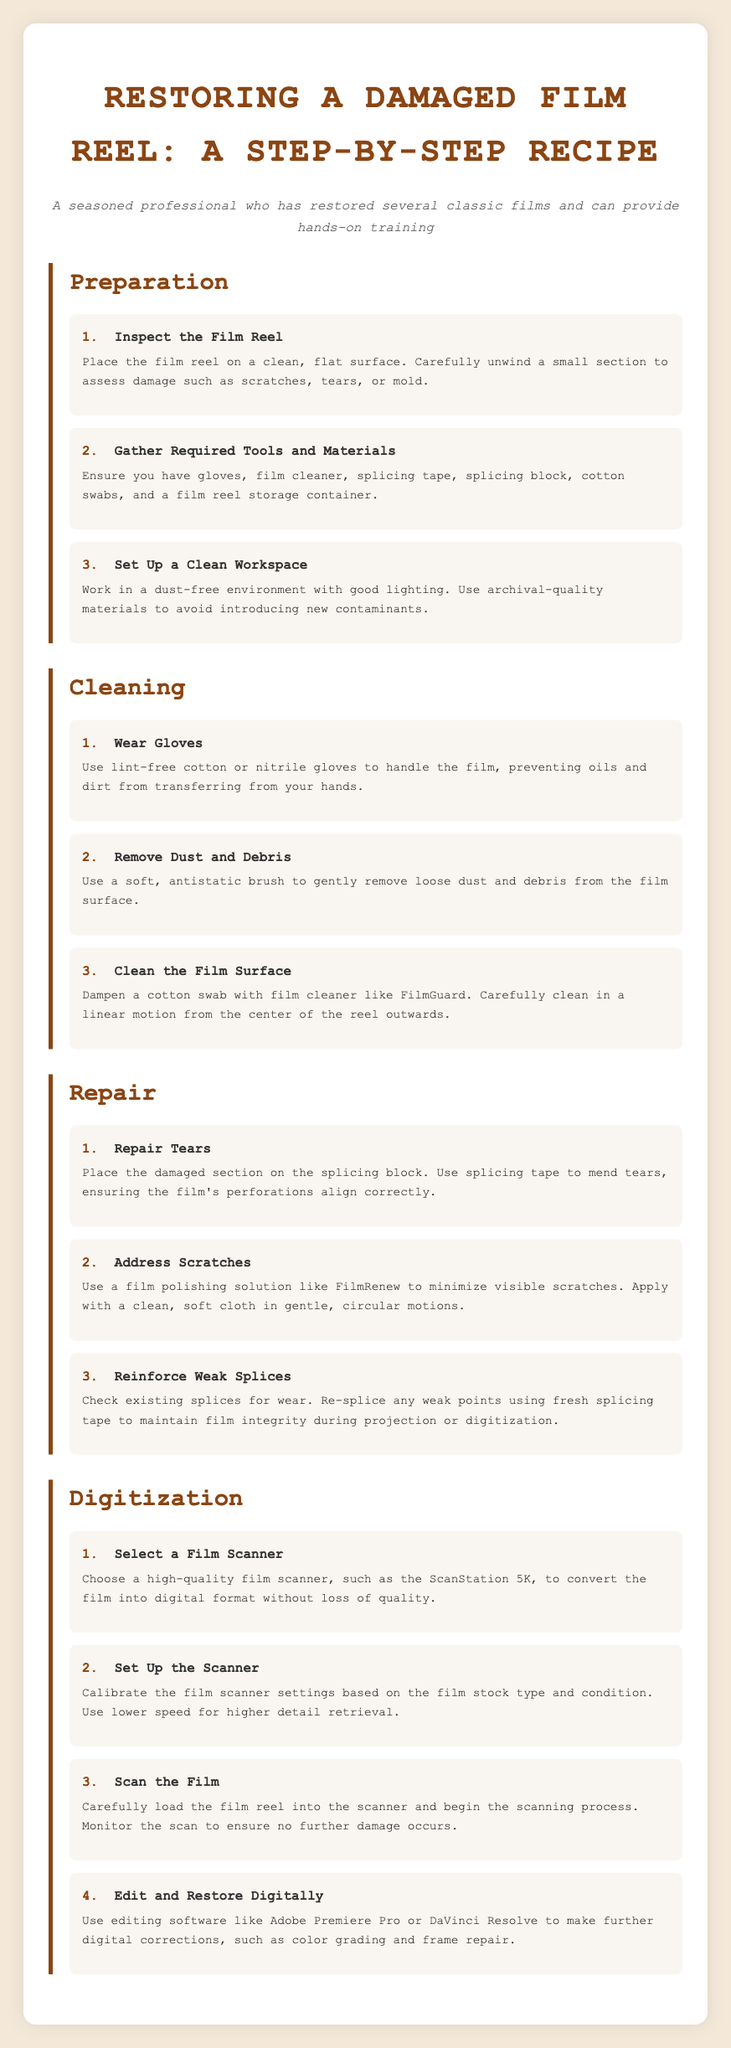What is the first step in the preparation process? The first step is to inspect the film reel for damage such as scratches, tears, or mold.
Answer: Inspect the Film Reel What should you wear while cleaning the film? Wearing gloves prevents oils and dirt from transferring from your hands to the film.
Answer: Gloves What tool is used to repair tears in the film? Splicing tape is used to mend tears in the film while ensuring perforations align.
Answer: Splicing tape Which solution minimizes visible scratches? Film polishing solution like FilmRenew minimizes visible scratches.
Answer: FilmRenew What is the name of a high-quality film scanner mentioned? The recipe card mentions the ScanStation 5K as a high-quality film scanner for digitization.
Answer: ScanStation 5K How should the film be cleaned? The film should be cleaned in a linear motion from the center of the reel outwards using a cotton swab.
Answer: Linear motion What is the purpose of calibrating the film scanner? Calibrating ensures the scanner settings are suitable based on the film stock type and condition.
Answer: Ensure proper settings How many steps are there in the cleaning section? There are three steps listed in the cleaning section of the document.
Answer: Three steps 